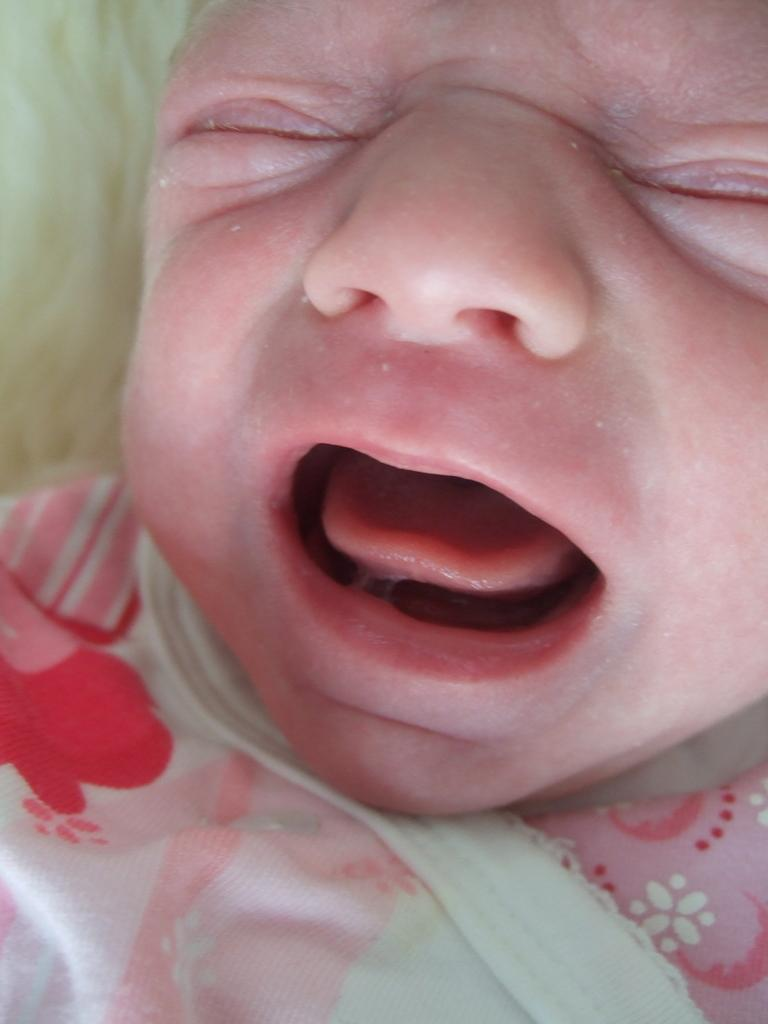What is the main subject of the image? There is a baby in the image. What is the baby doing in the image? The baby is crying. What type of twig is the baby holding in the image? There is no twig present in the image; the baby is not holding anything. Does the baby have a brother in the image? The provided facts do not mention the presence of a brother, so we cannot determine if the baby has a brother in the image. 